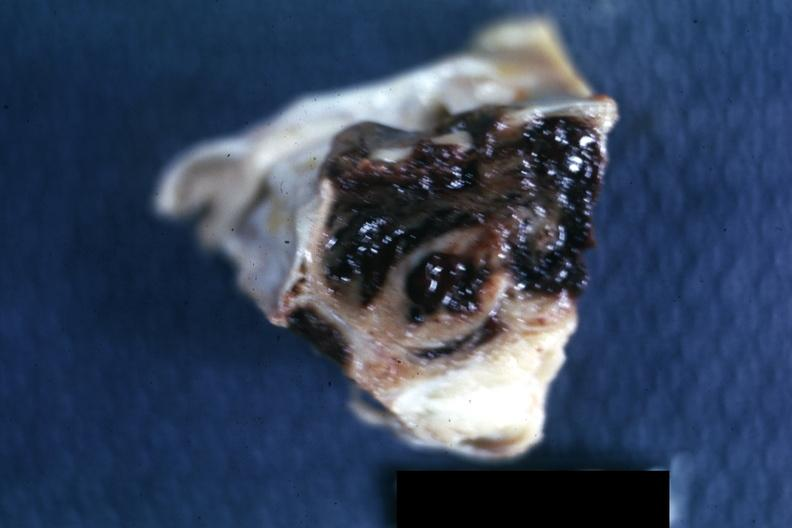does left ventricle hypertrophy show excised sella?
Answer the question using a single word or phrase. No 